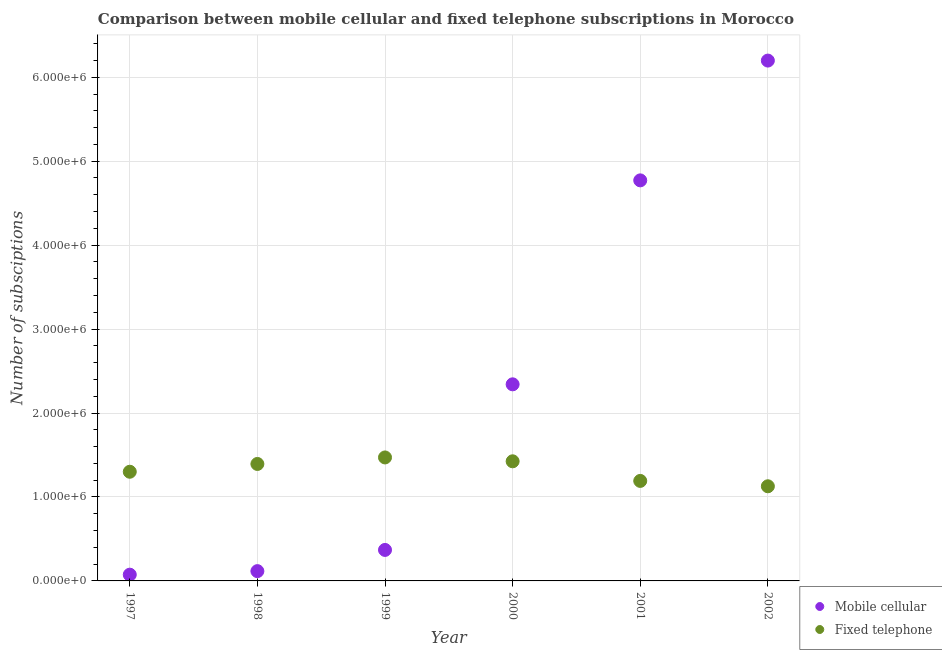How many different coloured dotlines are there?
Provide a succinct answer. 2. Is the number of dotlines equal to the number of legend labels?
Your response must be concise. Yes. What is the number of fixed telephone subscriptions in 1999?
Give a very brief answer. 1.47e+06. Across all years, what is the maximum number of fixed telephone subscriptions?
Make the answer very short. 1.47e+06. Across all years, what is the minimum number of mobile cellular subscriptions?
Provide a succinct answer. 7.45e+04. In which year was the number of mobile cellular subscriptions minimum?
Your response must be concise. 1997. What is the total number of fixed telephone subscriptions in the graph?
Make the answer very short. 7.91e+06. What is the difference between the number of mobile cellular subscriptions in 1999 and that in 2002?
Provide a short and direct response. -5.83e+06. What is the difference between the number of fixed telephone subscriptions in 1999 and the number of mobile cellular subscriptions in 2002?
Your response must be concise. -4.73e+06. What is the average number of fixed telephone subscriptions per year?
Provide a succinct answer. 1.32e+06. In the year 2001, what is the difference between the number of fixed telephone subscriptions and number of mobile cellular subscriptions?
Provide a succinct answer. -3.58e+06. What is the ratio of the number of fixed telephone subscriptions in 1998 to that in 2001?
Your answer should be compact. 1.17. Is the number of fixed telephone subscriptions in 1998 less than that in 2002?
Your response must be concise. No. Is the difference between the number of mobile cellular subscriptions in 1997 and 2000 greater than the difference between the number of fixed telephone subscriptions in 1997 and 2000?
Offer a very short reply. No. What is the difference between the highest and the second highest number of mobile cellular subscriptions?
Offer a very short reply. 1.43e+06. What is the difference between the highest and the lowest number of mobile cellular subscriptions?
Your response must be concise. 6.12e+06. Is the sum of the number of mobile cellular subscriptions in 1997 and 1999 greater than the maximum number of fixed telephone subscriptions across all years?
Provide a short and direct response. No. Does the number of mobile cellular subscriptions monotonically increase over the years?
Provide a short and direct response. Yes. Is the number of fixed telephone subscriptions strictly less than the number of mobile cellular subscriptions over the years?
Offer a terse response. No. How many years are there in the graph?
Your response must be concise. 6. What is the difference between two consecutive major ticks on the Y-axis?
Ensure brevity in your answer.  1.00e+06. Are the values on the major ticks of Y-axis written in scientific E-notation?
Offer a terse response. Yes. Does the graph contain any zero values?
Offer a very short reply. No. Does the graph contain grids?
Provide a succinct answer. Yes. How many legend labels are there?
Provide a succinct answer. 2. How are the legend labels stacked?
Make the answer very short. Vertical. What is the title of the graph?
Offer a very short reply. Comparison between mobile cellular and fixed telephone subscriptions in Morocco. What is the label or title of the Y-axis?
Keep it short and to the point. Number of subsciptions. What is the Number of subsciptions of Mobile cellular in 1997?
Your answer should be very brief. 7.45e+04. What is the Number of subsciptions in Fixed telephone in 1997?
Your response must be concise. 1.30e+06. What is the Number of subsciptions in Mobile cellular in 1998?
Make the answer very short. 1.17e+05. What is the Number of subsciptions of Fixed telephone in 1998?
Make the answer very short. 1.39e+06. What is the Number of subsciptions in Mobile cellular in 1999?
Provide a short and direct response. 3.69e+05. What is the Number of subsciptions in Fixed telephone in 1999?
Ensure brevity in your answer.  1.47e+06. What is the Number of subsciptions in Mobile cellular in 2000?
Provide a short and direct response. 2.34e+06. What is the Number of subsciptions in Fixed telephone in 2000?
Keep it short and to the point. 1.42e+06. What is the Number of subsciptions of Mobile cellular in 2001?
Your response must be concise. 4.77e+06. What is the Number of subsciptions of Fixed telephone in 2001?
Offer a very short reply. 1.19e+06. What is the Number of subsciptions of Mobile cellular in 2002?
Your answer should be very brief. 6.20e+06. What is the Number of subsciptions in Fixed telephone in 2002?
Provide a short and direct response. 1.13e+06. Across all years, what is the maximum Number of subsciptions in Mobile cellular?
Ensure brevity in your answer.  6.20e+06. Across all years, what is the maximum Number of subsciptions of Fixed telephone?
Keep it short and to the point. 1.47e+06. Across all years, what is the minimum Number of subsciptions of Mobile cellular?
Keep it short and to the point. 7.45e+04. Across all years, what is the minimum Number of subsciptions in Fixed telephone?
Give a very brief answer. 1.13e+06. What is the total Number of subsciptions of Mobile cellular in the graph?
Offer a very short reply. 1.39e+07. What is the total Number of subsciptions of Fixed telephone in the graph?
Offer a very short reply. 7.91e+06. What is the difference between the Number of subsciptions of Mobile cellular in 1997 and that in 1998?
Ensure brevity in your answer.  -4.22e+04. What is the difference between the Number of subsciptions of Fixed telephone in 1997 and that in 1998?
Offer a very short reply. -9.28e+04. What is the difference between the Number of subsciptions of Mobile cellular in 1997 and that in 1999?
Provide a short and direct response. -2.95e+05. What is the difference between the Number of subsciptions of Fixed telephone in 1997 and that in 1999?
Offer a very short reply. -1.70e+05. What is the difference between the Number of subsciptions of Mobile cellular in 1997 and that in 2000?
Provide a short and direct response. -2.27e+06. What is the difference between the Number of subsciptions of Fixed telephone in 1997 and that in 2000?
Offer a very short reply. -1.24e+05. What is the difference between the Number of subsciptions in Mobile cellular in 1997 and that in 2001?
Provide a short and direct response. -4.70e+06. What is the difference between the Number of subsciptions in Fixed telephone in 1997 and that in 2001?
Offer a very short reply. 1.09e+05. What is the difference between the Number of subsciptions in Mobile cellular in 1997 and that in 2002?
Provide a succinct answer. -6.12e+06. What is the difference between the Number of subsciptions of Fixed telephone in 1997 and that in 2002?
Give a very brief answer. 1.73e+05. What is the difference between the Number of subsciptions in Mobile cellular in 1998 and that in 1999?
Make the answer very short. -2.53e+05. What is the difference between the Number of subsciptions in Fixed telephone in 1998 and that in 1999?
Ensure brevity in your answer.  -7.76e+04. What is the difference between the Number of subsciptions of Mobile cellular in 1998 and that in 2000?
Your answer should be compact. -2.23e+06. What is the difference between the Number of subsciptions of Fixed telephone in 1998 and that in 2000?
Offer a terse response. -3.16e+04. What is the difference between the Number of subsciptions in Mobile cellular in 1998 and that in 2001?
Offer a terse response. -4.66e+06. What is the difference between the Number of subsciptions of Fixed telephone in 1998 and that in 2001?
Offer a very short reply. 2.02e+05. What is the difference between the Number of subsciptions of Mobile cellular in 1998 and that in 2002?
Make the answer very short. -6.08e+06. What is the difference between the Number of subsciptions in Fixed telephone in 1998 and that in 2002?
Provide a succinct answer. 2.66e+05. What is the difference between the Number of subsciptions of Mobile cellular in 1999 and that in 2000?
Provide a short and direct response. -1.97e+06. What is the difference between the Number of subsciptions in Fixed telephone in 1999 and that in 2000?
Your response must be concise. 4.60e+04. What is the difference between the Number of subsciptions in Mobile cellular in 1999 and that in 2001?
Your response must be concise. -4.40e+06. What is the difference between the Number of subsciptions in Fixed telephone in 1999 and that in 2001?
Ensure brevity in your answer.  2.80e+05. What is the difference between the Number of subsciptions of Mobile cellular in 1999 and that in 2002?
Give a very brief answer. -5.83e+06. What is the difference between the Number of subsciptions in Fixed telephone in 1999 and that in 2002?
Your response must be concise. 3.44e+05. What is the difference between the Number of subsciptions of Mobile cellular in 2000 and that in 2001?
Offer a very short reply. -2.43e+06. What is the difference between the Number of subsciptions in Fixed telephone in 2000 and that in 2001?
Offer a very short reply. 2.34e+05. What is the difference between the Number of subsciptions in Mobile cellular in 2000 and that in 2002?
Your response must be concise. -3.86e+06. What is the difference between the Number of subsciptions in Fixed telephone in 2000 and that in 2002?
Give a very brief answer. 2.98e+05. What is the difference between the Number of subsciptions of Mobile cellular in 2001 and that in 2002?
Your response must be concise. -1.43e+06. What is the difference between the Number of subsciptions of Fixed telephone in 2001 and that in 2002?
Make the answer very short. 6.39e+04. What is the difference between the Number of subsciptions in Mobile cellular in 1997 and the Number of subsciptions in Fixed telephone in 1998?
Give a very brief answer. -1.32e+06. What is the difference between the Number of subsciptions of Mobile cellular in 1997 and the Number of subsciptions of Fixed telephone in 1999?
Your answer should be compact. -1.40e+06. What is the difference between the Number of subsciptions of Mobile cellular in 1997 and the Number of subsciptions of Fixed telephone in 2000?
Ensure brevity in your answer.  -1.35e+06. What is the difference between the Number of subsciptions of Mobile cellular in 1997 and the Number of subsciptions of Fixed telephone in 2001?
Your answer should be compact. -1.12e+06. What is the difference between the Number of subsciptions of Mobile cellular in 1997 and the Number of subsciptions of Fixed telephone in 2002?
Provide a succinct answer. -1.05e+06. What is the difference between the Number of subsciptions in Mobile cellular in 1998 and the Number of subsciptions in Fixed telephone in 1999?
Keep it short and to the point. -1.35e+06. What is the difference between the Number of subsciptions in Mobile cellular in 1998 and the Number of subsciptions in Fixed telephone in 2000?
Offer a very short reply. -1.31e+06. What is the difference between the Number of subsciptions of Mobile cellular in 1998 and the Number of subsciptions of Fixed telephone in 2001?
Provide a succinct answer. -1.07e+06. What is the difference between the Number of subsciptions in Mobile cellular in 1998 and the Number of subsciptions in Fixed telephone in 2002?
Ensure brevity in your answer.  -1.01e+06. What is the difference between the Number of subsciptions in Mobile cellular in 1999 and the Number of subsciptions in Fixed telephone in 2000?
Your answer should be very brief. -1.06e+06. What is the difference between the Number of subsciptions of Mobile cellular in 1999 and the Number of subsciptions of Fixed telephone in 2001?
Your response must be concise. -8.22e+05. What is the difference between the Number of subsciptions of Mobile cellular in 1999 and the Number of subsciptions of Fixed telephone in 2002?
Offer a terse response. -7.58e+05. What is the difference between the Number of subsciptions in Mobile cellular in 2000 and the Number of subsciptions in Fixed telephone in 2001?
Make the answer very short. 1.15e+06. What is the difference between the Number of subsciptions of Mobile cellular in 2000 and the Number of subsciptions of Fixed telephone in 2002?
Offer a terse response. 1.21e+06. What is the difference between the Number of subsciptions of Mobile cellular in 2001 and the Number of subsciptions of Fixed telephone in 2002?
Ensure brevity in your answer.  3.64e+06. What is the average Number of subsciptions in Mobile cellular per year?
Your answer should be very brief. 2.31e+06. What is the average Number of subsciptions in Fixed telephone per year?
Make the answer very short. 1.32e+06. In the year 1997, what is the difference between the Number of subsciptions of Mobile cellular and Number of subsciptions of Fixed telephone?
Your answer should be compact. -1.23e+06. In the year 1998, what is the difference between the Number of subsciptions in Mobile cellular and Number of subsciptions in Fixed telephone?
Ensure brevity in your answer.  -1.28e+06. In the year 1999, what is the difference between the Number of subsciptions of Mobile cellular and Number of subsciptions of Fixed telephone?
Your response must be concise. -1.10e+06. In the year 2000, what is the difference between the Number of subsciptions in Mobile cellular and Number of subsciptions in Fixed telephone?
Offer a very short reply. 9.17e+05. In the year 2001, what is the difference between the Number of subsciptions in Mobile cellular and Number of subsciptions in Fixed telephone?
Offer a terse response. 3.58e+06. In the year 2002, what is the difference between the Number of subsciptions in Mobile cellular and Number of subsciptions in Fixed telephone?
Your answer should be compact. 5.07e+06. What is the ratio of the Number of subsciptions of Mobile cellular in 1997 to that in 1998?
Provide a short and direct response. 0.64. What is the ratio of the Number of subsciptions of Fixed telephone in 1997 to that in 1998?
Your response must be concise. 0.93. What is the ratio of the Number of subsciptions of Mobile cellular in 1997 to that in 1999?
Offer a terse response. 0.2. What is the ratio of the Number of subsciptions of Fixed telephone in 1997 to that in 1999?
Offer a very short reply. 0.88. What is the ratio of the Number of subsciptions of Mobile cellular in 1997 to that in 2000?
Ensure brevity in your answer.  0.03. What is the ratio of the Number of subsciptions of Fixed telephone in 1997 to that in 2000?
Ensure brevity in your answer.  0.91. What is the ratio of the Number of subsciptions in Mobile cellular in 1997 to that in 2001?
Offer a very short reply. 0.02. What is the ratio of the Number of subsciptions of Fixed telephone in 1997 to that in 2001?
Offer a very short reply. 1.09. What is the ratio of the Number of subsciptions of Mobile cellular in 1997 to that in 2002?
Your answer should be very brief. 0.01. What is the ratio of the Number of subsciptions in Fixed telephone in 1997 to that in 2002?
Keep it short and to the point. 1.15. What is the ratio of the Number of subsciptions in Mobile cellular in 1998 to that in 1999?
Offer a terse response. 0.32. What is the ratio of the Number of subsciptions of Fixed telephone in 1998 to that in 1999?
Your answer should be compact. 0.95. What is the ratio of the Number of subsciptions in Mobile cellular in 1998 to that in 2000?
Your response must be concise. 0.05. What is the ratio of the Number of subsciptions in Fixed telephone in 1998 to that in 2000?
Give a very brief answer. 0.98. What is the ratio of the Number of subsciptions of Mobile cellular in 1998 to that in 2001?
Your response must be concise. 0.02. What is the ratio of the Number of subsciptions of Fixed telephone in 1998 to that in 2001?
Your answer should be very brief. 1.17. What is the ratio of the Number of subsciptions in Mobile cellular in 1998 to that in 2002?
Keep it short and to the point. 0.02. What is the ratio of the Number of subsciptions of Fixed telephone in 1998 to that in 2002?
Provide a short and direct response. 1.24. What is the ratio of the Number of subsciptions in Mobile cellular in 1999 to that in 2000?
Your answer should be compact. 0.16. What is the ratio of the Number of subsciptions in Fixed telephone in 1999 to that in 2000?
Provide a succinct answer. 1.03. What is the ratio of the Number of subsciptions in Mobile cellular in 1999 to that in 2001?
Provide a succinct answer. 0.08. What is the ratio of the Number of subsciptions of Fixed telephone in 1999 to that in 2001?
Offer a terse response. 1.23. What is the ratio of the Number of subsciptions in Mobile cellular in 1999 to that in 2002?
Provide a short and direct response. 0.06. What is the ratio of the Number of subsciptions in Fixed telephone in 1999 to that in 2002?
Your answer should be compact. 1.3. What is the ratio of the Number of subsciptions in Mobile cellular in 2000 to that in 2001?
Give a very brief answer. 0.49. What is the ratio of the Number of subsciptions of Fixed telephone in 2000 to that in 2001?
Your answer should be very brief. 1.2. What is the ratio of the Number of subsciptions in Mobile cellular in 2000 to that in 2002?
Give a very brief answer. 0.38. What is the ratio of the Number of subsciptions in Fixed telephone in 2000 to that in 2002?
Provide a short and direct response. 1.26. What is the ratio of the Number of subsciptions in Mobile cellular in 2001 to that in 2002?
Ensure brevity in your answer.  0.77. What is the ratio of the Number of subsciptions in Fixed telephone in 2001 to that in 2002?
Make the answer very short. 1.06. What is the difference between the highest and the second highest Number of subsciptions of Mobile cellular?
Make the answer very short. 1.43e+06. What is the difference between the highest and the second highest Number of subsciptions of Fixed telephone?
Your answer should be very brief. 4.60e+04. What is the difference between the highest and the lowest Number of subsciptions of Mobile cellular?
Offer a terse response. 6.12e+06. What is the difference between the highest and the lowest Number of subsciptions in Fixed telephone?
Provide a succinct answer. 3.44e+05. 